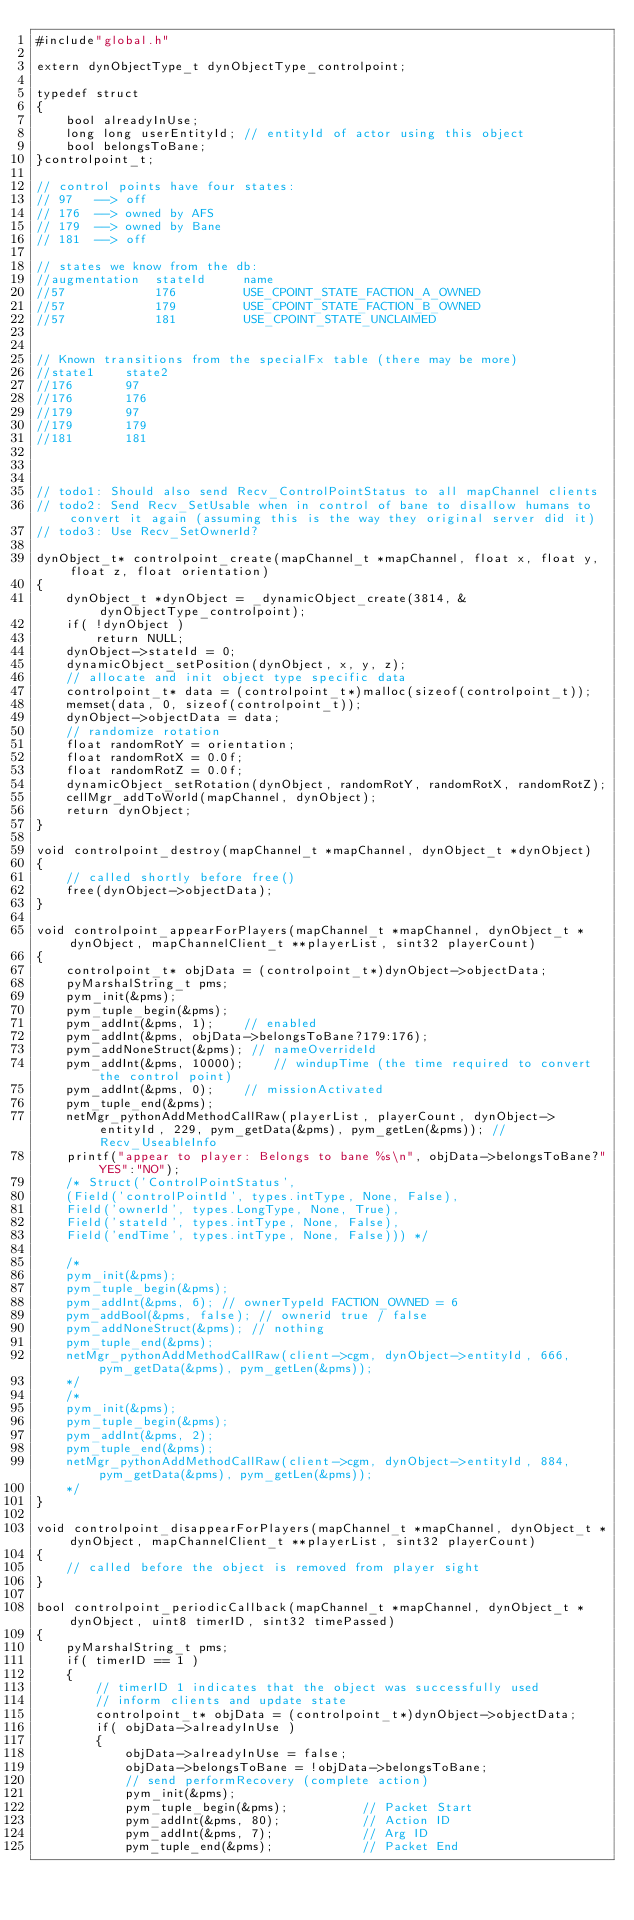<code> <loc_0><loc_0><loc_500><loc_500><_C++_>#include"global.h"

extern dynObjectType_t dynObjectType_controlpoint;

typedef struct  
{
	bool alreadyInUse;
	long long userEntityId; // entityId of actor using this object
	bool belongsToBane; 
}controlpoint_t;

// control points have four states:
// 97	-->	off
// 176	-->	owned by AFS
// 179	-->	owned by Bane
// 181	-->	off

// states we know from the db:
//augmentation	stateId		name
//57			176			USE_CPOINT_STATE_FACTION_A_OWNED
//57			179			USE_CPOINT_STATE_FACTION_B_OWNED
//57			181			USE_CPOINT_STATE_UNCLAIMED


// Known transitions from the specialFx table (there may be more)
//state1	state2
//176		97
//176		176
//179		97
//179		179
//181		181



// todo1: Should also send Recv_ControlPointStatus to all mapChannel clients
// todo2: Send Recv_SetUsable when in control of bane to disallow humans to convert it again (assuming this is the way they original server did it)
// todo3: Use Recv_SetOwnerId?

dynObject_t* controlpoint_create(mapChannel_t *mapChannel, float x, float y, float z, float orientation)
{
	dynObject_t *dynObject = _dynamicObject_create(3814, &dynObjectType_controlpoint);
	if( !dynObject )
		return NULL;
	dynObject->stateId = 0;
	dynamicObject_setPosition(dynObject, x, y, z);
	// allocate and init object type specific data
	controlpoint_t* data = (controlpoint_t*)malloc(sizeof(controlpoint_t));
	memset(data, 0, sizeof(controlpoint_t));
	dynObject->objectData = data;
	// randomize rotation
	float randomRotY = orientation;
	float randomRotX = 0.0f;
	float randomRotZ = 0.0f;
	dynamicObject_setRotation(dynObject, randomRotY, randomRotX, randomRotZ);
	cellMgr_addToWorld(mapChannel, dynObject);
	return dynObject;
}

void controlpoint_destroy(mapChannel_t *mapChannel, dynObject_t *dynObject)
{
	// called shortly before free()
	free(dynObject->objectData);
}

void controlpoint_appearForPlayers(mapChannel_t *mapChannel, dynObject_t *dynObject, mapChannelClient_t **playerList, sint32 playerCount)
{
	controlpoint_t* objData = (controlpoint_t*)dynObject->objectData;
	pyMarshalString_t pms;
	pym_init(&pms);
	pym_tuple_begin(&pms);
	pym_addInt(&pms, 1);	// enabled
	pym_addInt(&pms, objData->belongsToBane?179:176);
	pym_addNoneStruct(&pms); // nameOverrideId
	pym_addInt(&pms, 10000);	// windupTime (the time required to convert the control point)
	pym_addInt(&pms, 0);	// missionActivated
	pym_tuple_end(&pms);
	netMgr_pythonAddMethodCallRaw(playerList, playerCount, dynObject->entityId, 229, pym_getData(&pms), pym_getLen(&pms)); // Recv_UseableInfo
	printf("appear to player: Belongs to bane %s\n", objData->belongsToBane?"YES":"NO");
	/* Struct('ControlPointStatus', 
	(Field('controlPointId', types.intType, None, False),
	Field('ownerId', types.LongType, None, True),
	Field('stateId', types.intType, None, False),
	Field('endTime', types.intType, None, False))) */
	
	/*
	pym_init(&pms);
	pym_tuple_begin(&pms);
	pym_addInt(&pms, 6); // ownerTypeId FACTION_OWNED = 6
	pym_addBool(&pms, false); // ownerid true / false
	pym_addNoneStruct(&pms); // nothing
	pym_tuple_end(&pms);
	netMgr_pythonAddMethodCallRaw(client->cgm, dynObject->entityId, 666, pym_getData(&pms), pym_getLen(&pms));
	*/
	/*
	pym_init(&pms);
	pym_tuple_begin(&pms);
	pym_addInt(&pms, 2);
	pym_tuple_end(&pms);
	netMgr_pythonAddMethodCallRaw(client->cgm, dynObject->entityId, 884, pym_getData(&pms), pym_getLen(&pms));
	*/
}

void controlpoint_disappearForPlayers(mapChannel_t *mapChannel, dynObject_t *dynObject, mapChannelClient_t **playerList, sint32 playerCount)
{
	// called before the object is removed from player sight
}

bool controlpoint_periodicCallback(mapChannel_t *mapChannel, dynObject_t *dynObject, uint8 timerID, sint32 timePassed)
{
	pyMarshalString_t pms;
	if( timerID == 1 )
	{
		// timerID 1 indicates that the object was successfully used
		// inform clients and update state
		controlpoint_t* objData = (controlpoint_t*)dynObject->objectData;
		if( objData->alreadyInUse )
		{
			objData->alreadyInUse = false;
			objData->belongsToBane = !objData->belongsToBane;
			// send performRecovery (complete action)
			pym_init(&pms);
			pym_tuple_begin(&pms);  		// Packet Start
			pym_addInt(&pms, 80);			// Action ID
			pym_addInt(&pms, 7);			// Arg ID
			pym_tuple_end(&pms); 			// Packet End</code> 